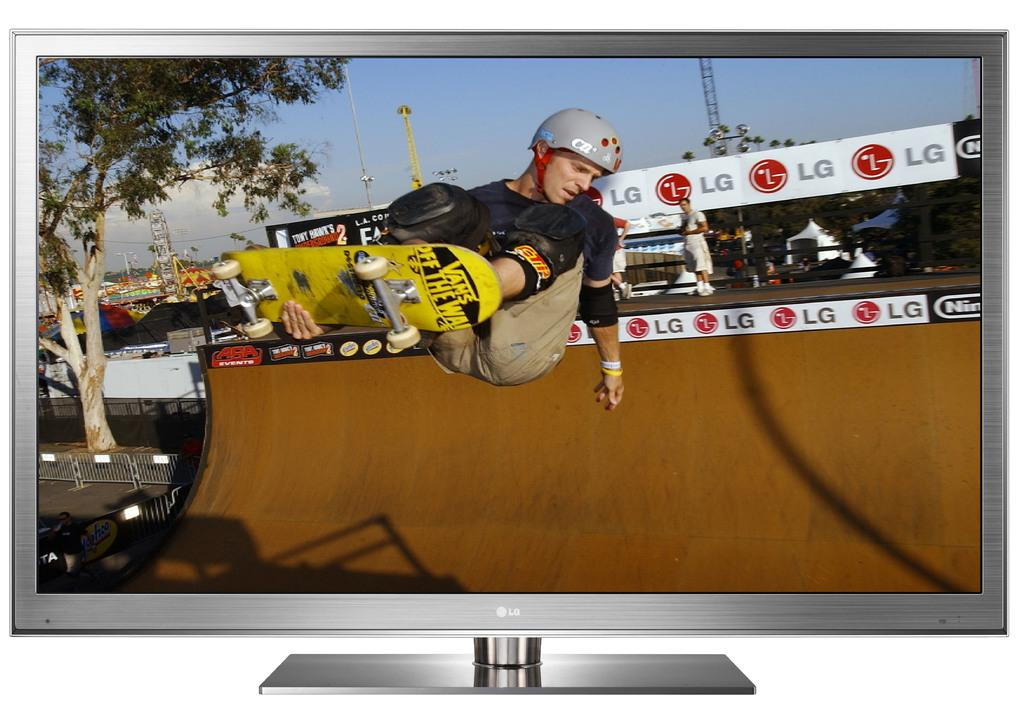Provide a one-sentence caption for the provided image. a skater riding on a ramp with an LG ad near. 